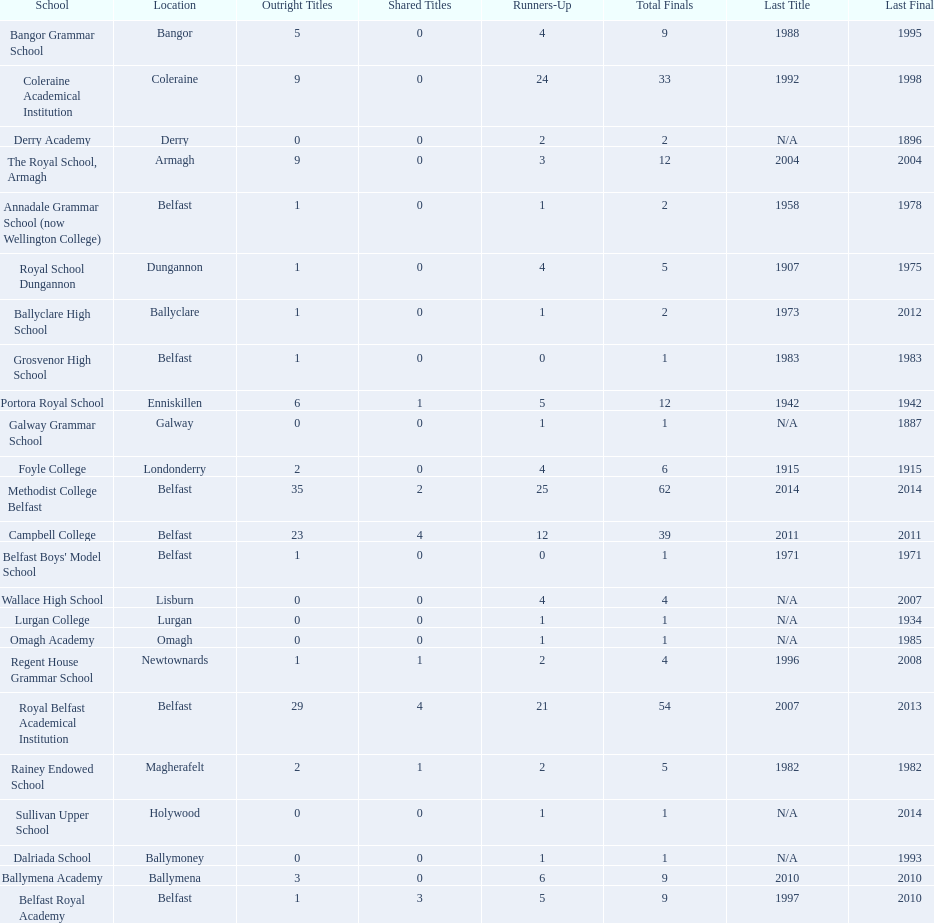Which schools are listed? Methodist College Belfast, Royal Belfast Academical Institution, Campbell College, Coleraine Academical Institution, The Royal School, Armagh, Portora Royal School, Bangor Grammar School, Ballymena Academy, Rainey Endowed School, Foyle College, Belfast Royal Academy, Regent House Grammar School, Royal School Dungannon, Annadale Grammar School (now Wellington College), Ballyclare High School, Belfast Boys' Model School, Grosvenor High School, Wallace High School, Derry Academy, Dalriada School, Galway Grammar School, Lurgan College, Omagh Academy, Sullivan Upper School. When did campbell college win the title last? 2011. When did regent house grammar school win the title last? 1996. Of those two who had the most recent title win? Campbell College. 